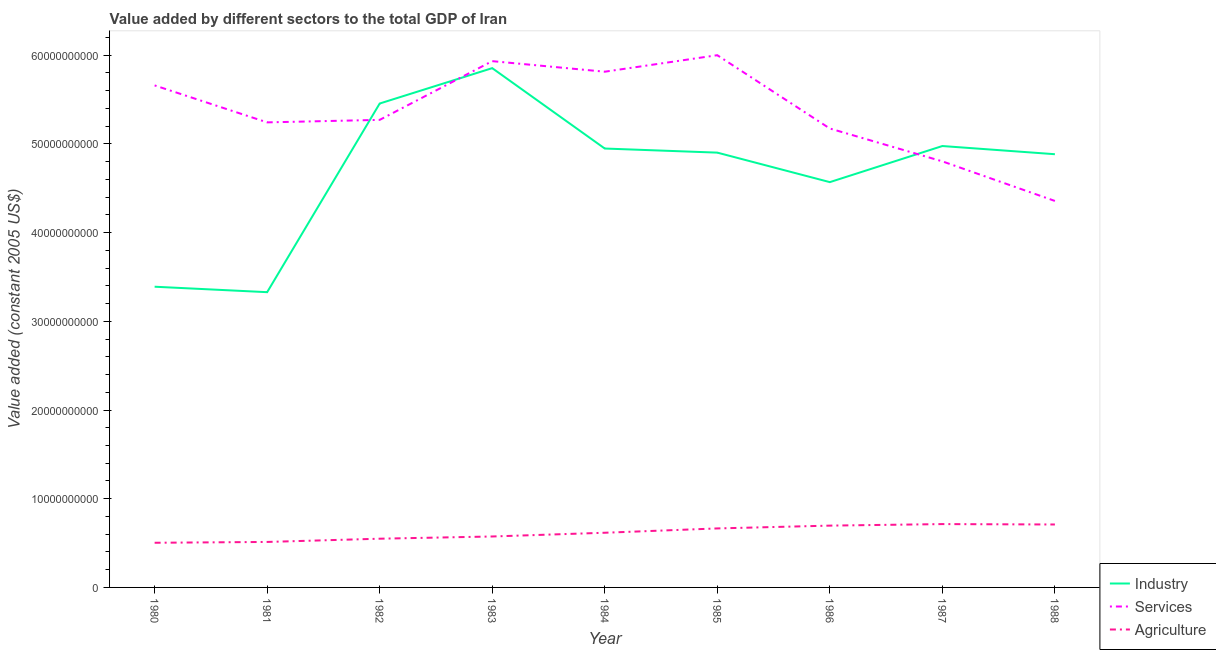Does the line corresponding to value added by industrial sector intersect with the line corresponding to value added by agricultural sector?
Provide a succinct answer. No. Is the number of lines equal to the number of legend labels?
Give a very brief answer. Yes. What is the value added by services in 1983?
Your answer should be compact. 5.93e+1. Across all years, what is the maximum value added by agricultural sector?
Ensure brevity in your answer.  7.14e+09. Across all years, what is the minimum value added by services?
Keep it short and to the point. 4.36e+1. In which year was the value added by industrial sector maximum?
Ensure brevity in your answer.  1983. In which year was the value added by agricultural sector minimum?
Offer a terse response. 1980. What is the total value added by industrial sector in the graph?
Give a very brief answer. 4.23e+11. What is the difference between the value added by industrial sector in 1983 and that in 1988?
Provide a succinct answer. 9.70e+09. What is the difference between the value added by industrial sector in 1988 and the value added by services in 1987?
Give a very brief answer. 8.06e+08. What is the average value added by agricultural sector per year?
Provide a short and direct response. 6.16e+09. In the year 1983, what is the difference between the value added by services and value added by agricultural sector?
Offer a very short reply. 5.36e+1. In how many years, is the value added by industrial sector greater than 40000000000 US$?
Keep it short and to the point. 7. What is the ratio of the value added by services in 1980 to that in 1987?
Your answer should be very brief. 1.18. Is the value added by services in 1980 less than that in 1986?
Your answer should be compact. No. Is the difference between the value added by agricultural sector in 1982 and 1985 greater than the difference between the value added by services in 1982 and 1985?
Offer a terse response. Yes. What is the difference between the highest and the second highest value added by services?
Your answer should be very brief. 6.70e+08. What is the difference between the highest and the lowest value added by agricultural sector?
Make the answer very short. 2.11e+09. Is the value added by industrial sector strictly greater than the value added by services over the years?
Keep it short and to the point. No. How many lines are there?
Provide a succinct answer. 3. What is the difference between two consecutive major ticks on the Y-axis?
Give a very brief answer. 1.00e+1. Are the values on the major ticks of Y-axis written in scientific E-notation?
Offer a terse response. No. Does the graph contain any zero values?
Your response must be concise. No. Where does the legend appear in the graph?
Provide a short and direct response. Bottom right. What is the title of the graph?
Offer a terse response. Value added by different sectors to the total GDP of Iran. Does "Oil" appear as one of the legend labels in the graph?
Offer a very short reply. No. What is the label or title of the Y-axis?
Your response must be concise. Value added (constant 2005 US$). What is the Value added (constant 2005 US$) of Industry in 1980?
Ensure brevity in your answer.  3.39e+1. What is the Value added (constant 2005 US$) in Services in 1980?
Provide a succinct answer. 5.66e+1. What is the Value added (constant 2005 US$) of Agriculture in 1980?
Provide a short and direct response. 5.04e+09. What is the Value added (constant 2005 US$) in Industry in 1981?
Offer a very short reply. 3.33e+1. What is the Value added (constant 2005 US$) in Services in 1981?
Ensure brevity in your answer.  5.24e+1. What is the Value added (constant 2005 US$) of Agriculture in 1981?
Give a very brief answer. 5.13e+09. What is the Value added (constant 2005 US$) of Industry in 1982?
Give a very brief answer. 5.46e+1. What is the Value added (constant 2005 US$) in Services in 1982?
Make the answer very short. 5.27e+1. What is the Value added (constant 2005 US$) of Agriculture in 1982?
Your answer should be compact. 5.49e+09. What is the Value added (constant 2005 US$) in Industry in 1983?
Ensure brevity in your answer.  5.85e+1. What is the Value added (constant 2005 US$) of Services in 1983?
Make the answer very short. 5.93e+1. What is the Value added (constant 2005 US$) of Agriculture in 1983?
Ensure brevity in your answer.  5.74e+09. What is the Value added (constant 2005 US$) in Industry in 1984?
Provide a succinct answer. 4.95e+1. What is the Value added (constant 2005 US$) of Services in 1984?
Give a very brief answer. 5.81e+1. What is the Value added (constant 2005 US$) in Agriculture in 1984?
Ensure brevity in your answer.  6.17e+09. What is the Value added (constant 2005 US$) in Industry in 1985?
Your response must be concise. 4.90e+1. What is the Value added (constant 2005 US$) in Services in 1985?
Make the answer very short. 6.00e+1. What is the Value added (constant 2005 US$) of Agriculture in 1985?
Provide a succinct answer. 6.65e+09. What is the Value added (constant 2005 US$) in Industry in 1986?
Make the answer very short. 4.57e+1. What is the Value added (constant 2005 US$) of Services in 1986?
Your answer should be compact. 5.17e+1. What is the Value added (constant 2005 US$) of Agriculture in 1986?
Offer a terse response. 6.97e+09. What is the Value added (constant 2005 US$) in Industry in 1987?
Keep it short and to the point. 4.98e+1. What is the Value added (constant 2005 US$) of Services in 1987?
Make the answer very short. 4.80e+1. What is the Value added (constant 2005 US$) in Agriculture in 1987?
Your answer should be very brief. 7.14e+09. What is the Value added (constant 2005 US$) in Industry in 1988?
Ensure brevity in your answer.  4.88e+1. What is the Value added (constant 2005 US$) of Services in 1988?
Provide a succinct answer. 4.36e+1. What is the Value added (constant 2005 US$) in Agriculture in 1988?
Make the answer very short. 7.10e+09. Across all years, what is the maximum Value added (constant 2005 US$) in Industry?
Ensure brevity in your answer.  5.85e+1. Across all years, what is the maximum Value added (constant 2005 US$) of Services?
Your response must be concise. 6.00e+1. Across all years, what is the maximum Value added (constant 2005 US$) in Agriculture?
Offer a terse response. 7.14e+09. Across all years, what is the minimum Value added (constant 2005 US$) of Industry?
Make the answer very short. 3.33e+1. Across all years, what is the minimum Value added (constant 2005 US$) in Services?
Your response must be concise. 4.36e+1. Across all years, what is the minimum Value added (constant 2005 US$) of Agriculture?
Give a very brief answer. 5.04e+09. What is the total Value added (constant 2005 US$) in Industry in the graph?
Make the answer very short. 4.23e+11. What is the total Value added (constant 2005 US$) of Services in the graph?
Keep it short and to the point. 4.83e+11. What is the total Value added (constant 2005 US$) of Agriculture in the graph?
Provide a succinct answer. 5.54e+1. What is the difference between the Value added (constant 2005 US$) of Industry in 1980 and that in 1981?
Keep it short and to the point. 6.14e+08. What is the difference between the Value added (constant 2005 US$) of Services in 1980 and that in 1981?
Offer a terse response. 4.17e+09. What is the difference between the Value added (constant 2005 US$) of Agriculture in 1980 and that in 1981?
Make the answer very short. -9.32e+07. What is the difference between the Value added (constant 2005 US$) of Industry in 1980 and that in 1982?
Provide a short and direct response. -2.07e+1. What is the difference between the Value added (constant 2005 US$) of Services in 1980 and that in 1982?
Your response must be concise. 3.89e+09. What is the difference between the Value added (constant 2005 US$) in Agriculture in 1980 and that in 1982?
Provide a succinct answer. -4.58e+08. What is the difference between the Value added (constant 2005 US$) in Industry in 1980 and that in 1983?
Offer a terse response. -2.46e+1. What is the difference between the Value added (constant 2005 US$) in Services in 1980 and that in 1983?
Your answer should be very brief. -2.74e+09. What is the difference between the Value added (constant 2005 US$) of Agriculture in 1980 and that in 1983?
Provide a succinct answer. -7.09e+08. What is the difference between the Value added (constant 2005 US$) in Industry in 1980 and that in 1984?
Keep it short and to the point. -1.56e+1. What is the difference between the Value added (constant 2005 US$) of Services in 1980 and that in 1984?
Your answer should be compact. -1.54e+09. What is the difference between the Value added (constant 2005 US$) in Agriculture in 1980 and that in 1984?
Your answer should be very brief. -1.13e+09. What is the difference between the Value added (constant 2005 US$) of Industry in 1980 and that in 1985?
Provide a succinct answer. -1.51e+1. What is the difference between the Value added (constant 2005 US$) of Services in 1980 and that in 1985?
Your answer should be compact. -3.40e+09. What is the difference between the Value added (constant 2005 US$) in Agriculture in 1980 and that in 1985?
Give a very brief answer. -1.62e+09. What is the difference between the Value added (constant 2005 US$) in Industry in 1980 and that in 1986?
Make the answer very short. -1.18e+1. What is the difference between the Value added (constant 2005 US$) of Services in 1980 and that in 1986?
Your answer should be compact. 4.86e+09. What is the difference between the Value added (constant 2005 US$) in Agriculture in 1980 and that in 1986?
Provide a succinct answer. -1.93e+09. What is the difference between the Value added (constant 2005 US$) of Industry in 1980 and that in 1987?
Provide a short and direct response. -1.59e+1. What is the difference between the Value added (constant 2005 US$) of Services in 1980 and that in 1987?
Your response must be concise. 8.56e+09. What is the difference between the Value added (constant 2005 US$) of Agriculture in 1980 and that in 1987?
Provide a succinct answer. -2.11e+09. What is the difference between the Value added (constant 2005 US$) of Industry in 1980 and that in 1988?
Offer a terse response. -1.49e+1. What is the difference between the Value added (constant 2005 US$) of Services in 1980 and that in 1988?
Make the answer very short. 1.30e+1. What is the difference between the Value added (constant 2005 US$) in Agriculture in 1980 and that in 1988?
Make the answer very short. -2.06e+09. What is the difference between the Value added (constant 2005 US$) in Industry in 1981 and that in 1982?
Offer a terse response. -2.13e+1. What is the difference between the Value added (constant 2005 US$) in Services in 1981 and that in 1982?
Your response must be concise. -2.82e+08. What is the difference between the Value added (constant 2005 US$) of Agriculture in 1981 and that in 1982?
Offer a very short reply. -3.65e+08. What is the difference between the Value added (constant 2005 US$) of Industry in 1981 and that in 1983?
Make the answer very short. -2.53e+1. What is the difference between the Value added (constant 2005 US$) in Services in 1981 and that in 1983?
Make the answer very short. -6.90e+09. What is the difference between the Value added (constant 2005 US$) in Agriculture in 1981 and that in 1983?
Provide a short and direct response. -6.15e+08. What is the difference between the Value added (constant 2005 US$) of Industry in 1981 and that in 1984?
Your response must be concise. -1.62e+1. What is the difference between the Value added (constant 2005 US$) of Services in 1981 and that in 1984?
Keep it short and to the point. -5.71e+09. What is the difference between the Value added (constant 2005 US$) in Agriculture in 1981 and that in 1984?
Provide a succinct answer. -1.04e+09. What is the difference between the Value added (constant 2005 US$) of Industry in 1981 and that in 1985?
Provide a succinct answer. -1.57e+1. What is the difference between the Value added (constant 2005 US$) of Services in 1981 and that in 1985?
Ensure brevity in your answer.  -7.57e+09. What is the difference between the Value added (constant 2005 US$) of Agriculture in 1981 and that in 1985?
Keep it short and to the point. -1.52e+09. What is the difference between the Value added (constant 2005 US$) of Industry in 1981 and that in 1986?
Provide a short and direct response. -1.24e+1. What is the difference between the Value added (constant 2005 US$) of Services in 1981 and that in 1986?
Your answer should be very brief. 6.92e+08. What is the difference between the Value added (constant 2005 US$) of Agriculture in 1981 and that in 1986?
Give a very brief answer. -1.84e+09. What is the difference between the Value added (constant 2005 US$) in Industry in 1981 and that in 1987?
Provide a short and direct response. -1.65e+1. What is the difference between the Value added (constant 2005 US$) of Services in 1981 and that in 1987?
Make the answer very short. 4.40e+09. What is the difference between the Value added (constant 2005 US$) in Agriculture in 1981 and that in 1987?
Keep it short and to the point. -2.01e+09. What is the difference between the Value added (constant 2005 US$) of Industry in 1981 and that in 1988?
Give a very brief answer. -1.56e+1. What is the difference between the Value added (constant 2005 US$) in Services in 1981 and that in 1988?
Provide a succinct answer. 8.86e+09. What is the difference between the Value added (constant 2005 US$) in Agriculture in 1981 and that in 1988?
Provide a succinct answer. -1.97e+09. What is the difference between the Value added (constant 2005 US$) of Industry in 1982 and that in 1983?
Provide a succinct answer. -3.99e+09. What is the difference between the Value added (constant 2005 US$) of Services in 1982 and that in 1983?
Provide a succinct answer. -6.62e+09. What is the difference between the Value added (constant 2005 US$) in Agriculture in 1982 and that in 1983?
Provide a succinct answer. -2.50e+08. What is the difference between the Value added (constant 2005 US$) of Industry in 1982 and that in 1984?
Make the answer very short. 5.08e+09. What is the difference between the Value added (constant 2005 US$) of Services in 1982 and that in 1984?
Give a very brief answer. -5.43e+09. What is the difference between the Value added (constant 2005 US$) in Agriculture in 1982 and that in 1984?
Provide a succinct answer. -6.72e+08. What is the difference between the Value added (constant 2005 US$) in Industry in 1982 and that in 1985?
Give a very brief answer. 5.54e+09. What is the difference between the Value added (constant 2005 US$) in Services in 1982 and that in 1985?
Provide a short and direct response. -7.29e+09. What is the difference between the Value added (constant 2005 US$) in Agriculture in 1982 and that in 1985?
Your response must be concise. -1.16e+09. What is the difference between the Value added (constant 2005 US$) in Industry in 1982 and that in 1986?
Give a very brief answer. 8.86e+09. What is the difference between the Value added (constant 2005 US$) of Services in 1982 and that in 1986?
Your answer should be very brief. 9.74e+08. What is the difference between the Value added (constant 2005 US$) in Agriculture in 1982 and that in 1986?
Ensure brevity in your answer.  -1.47e+09. What is the difference between the Value added (constant 2005 US$) in Industry in 1982 and that in 1987?
Offer a very short reply. 4.79e+09. What is the difference between the Value added (constant 2005 US$) in Services in 1982 and that in 1987?
Your answer should be compact. 4.68e+09. What is the difference between the Value added (constant 2005 US$) in Agriculture in 1982 and that in 1987?
Your answer should be compact. -1.65e+09. What is the difference between the Value added (constant 2005 US$) in Industry in 1982 and that in 1988?
Offer a very short reply. 5.72e+09. What is the difference between the Value added (constant 2005 US$) of Services in 1982 and that in 1988?
Give a very brief answer. 9.14e+09. What is the difference between the Value added (constant 2005 US$) in Agriculture in 1982 and that in 1988?
Give a very brief answer. -1.60e+09. What is the difference between the Value added (constant 2005 US$) of Industry in 1983 and that in 1984?
Keep it short and to the point. 9.06e+09. What is the difference between the Value added (constant 2005 US$) of Services in 1983 and that in 1984?
Your answer should be very brief. 1.19e+09. What is the difference between the Value added (constant 2005 US$) of Agriculture in 1983 and that in 1984?
Ensure brevity in your answer.  -4.22e+08. What is the difference between the Value added (constant 2005 US$) of Industry in 1983 and that in 1985?
Give a very brief answer. 9.53e+09. What is the difference between the Value added (constant 2005 US$) in Services in 1983 and that in 1985?
Provide a short and direct response. -6.70e+08. What is the difference between the Value added (constant 2005 US$) in Agriculture in 1983 and that in 1985?
Provide a succinct answer. -9.09e+08. What is the difference between the Value added (constant 2005 US$) of Industry in 1983 and that in 1986?
Provide a short and direct response. 1.29e+1. What is the difference between the Value added (constant 2005 US$) of Services in 1983 and that in 1986?
Your answer should be compact. 7.60e+09. What is the difference between the Value added (constant 2005 US$) of Agriculture in 1983 and that in 1986?
Keep it short and to the point. -1.22e+09. What is the difference between the Value added (constant 2005 US$) of Industry in 1983 and that in 1987?
Your answer should be very brief. 8.78e+09. What is the difference between the Value added (constant 2005 US$) in Services in 1983 and that in 1987?
Your response must be concise. 1.13e+1. What is the difference between the Value added (constant 2005 US$) of Agriculture in 1983 and that in 1987?
Give a very brief answer. -1.40e+09. What is the difference between the Value added (constant 2005 US$) in Industry in 1983 and that in 1988?
Your response must be concise. 9.70e+09. What is the difference between the Value added (constant 2005 US$) of Services in 1983 and that in 1988?
Make the answer very short. 1.58e+1. What is the difference between the Value added (constant 2005 US$) of Agriculture in 1983 and that in 1988?
Provide a succinct answer. -1.35e+09. What is the difference between the Value added (constant 2005 US$) of Industry in 1984 and that in 1985?
Provide a succinct answer. 4.61e+08. What is the difference between the Value added (constant 2005 US$) in Services in 1984 and that in 1985?
Give a very brief answer. -1.86e+09. What is the difference between the Value added (constant 2005 US$) in Agriculture in 1984 and that in 1985?
Offer a very short reply. -4.87e+08. What is the difference between the Value added (constant 2005 US$) in Industry in 1984 and that in 1986?
Your answer should be very brief. 3.79e+09. What is the difference between the Value added (constant 2005 US$) of Services in 1984 and that in 1986?
Provide a succinct answer. 6.40e+09. What is the difference between the Value added (constant 2005 US$) of Agriculture in 1984 and that in 1986?
Your answer should be very brief. -8.03e+08. What is the difference between the Value added (constant 2005 US$) in Industry in 1984 and that in 1987?
Provide a succinct answer. -2.82e+08. What is the difference between the Value added (constant 2005 US$) in Services in 1984 and that in 1987?
Your answer should be very brief. 1.01e+1. What is the difference between the Value added (constant 2005 US$) of Agriculture in 1984 and that in 1987?
Keep it short and to the point. -9.76e+08. What is the difference between the Value added (constant 2005 US$) of Industry in 1984 and that in 1988?
Your response must be concise. 6.40e+08. What is the difference between the Value added (constant 2005 US$) of Services in 1984 and that in 1988?
Provide a succinct answer. 1.46e+1. What is the difference between the Value added (constant 2005 US$) in Agriculture in 1984 and that in 1988?
Your response must be concise. -9.30e+08. What is the difference between the Value added (constant 2005 US$) in Industry in 1985 and that in 1986?
Provide a short and direct response. 3.33e+09. What is the difference between the Value added (constant 2005 US$) of Services in 1985 and that in 1986?
Your response must be concise. 8.26e+09. What is the difference between the Value added (constant 2005 US$) in Agriculture in 1985 and that in 1986?
Offer a terse response. -3.16e+08. What is the difference between the Value added (constant 2005 US$) in Industry in 1985 and that in 1987?
Keep it short and to the point. -7.43e+08. What is the difference between the Value added (constant 2005 US$) of Services in 1985 and that in 1987?
Ensure brevity in your answer.  1.20e+1. What is the difference between the Value added (constant 2005 US$) of Agriculture in 1985 and that in 1987?
Your answer should be compact. -4.89e+08. What is the difference between the Value added (constant 2005 US$) in Industry in 1985 and that in 1988?
Offer a terse response. 1.79e+08. What is the difference between the Value added (constant 2005 US$) in Services in 1985 and that in 1988?
Your response must be concise. 1.64e+1. What is the difference between the Value added (constant 2005 US$) of Agriculture in 1985 and that in 1988?
Provide a succinct answer. -4.43e+08. What is the difference between the Value added (constant 2005 US$) in Industry in 1986 and that in 1987?
Make the answer very short. -4.07e+09. What is the difference between the Value added (constant 2005 US$) of Services in 1986 and that in 1987?
Give a very brief answer. 3.70e+09. What is the difference between the Value added (constant 2005 US$) in Agriculture in 1986 and that in 1987?
Your answer should be compact. -1.73e+08. What is the difference between the Value added (constant 2005 US$) of Industry in 1986 and that in 1988?
Your answer should be compact. -3.15e+09. What is the difference between the Value added (constant 2005 US$) in Services in 1986 and that in 1988?
Your answer should be compact. 8.17e+09. What is the difference between the Value added (constant 2005 US$) of Agriculture in 1986 and that in 1988?
Make the answer very short. -1.27e+08. What is the difference between the Value added (constant 2005 US$) in Industry in 1987 and that in 1988?
Offer a very short reply. 9.22e+08. What is the difference between the Value added (constant 2005 US$) of Services in 1987 and that in 1988?
Offer a very short reply. 4.46e+09. What is the difference between the Value added (constant 2005 US$) of Agriculture in 1987 and that in 1988?
Provide a succinct answer. 4.59e+07. What is the difference between the Value added (constant 2005 US$) of Industry in 1980 and the Value added (constant 2005 US$) of Services in 1981?
Provide a succinct answer. -1.85e+1. What is the difference between the Value added (constant 2005 US$) in Industry in 1980 and the Value added (constant 2005 US$) in Agriculture in 1981?
Give a very brief answer. 2.88e+1. What is the difference between the Value added (constant 2005 US$) in Services in 1980 and the Value added (constant 2005 US$) in Agriculture in 1981?
Provide a short and direct response. 5.15e+1. What is the difference between the Value added (constant 2005 US$) of Industry in 1980 and the Value added (constant 2005 US$) of Services in 1982?
Provide a short and direct response. -1.88e+1. What is the difference between the Value added (constant 2005 US$) of Industry in 1980 and the Value added (constant 2005 US$) of Agriculture in 1982?
Make the answer very short. 2.84e+1. What is the difference between the Value added (constant 2005 US$) in Services in 1980 and the Value added (constant 2005 US$) in Agriculture in 1982?
Your answer should be very brief. 5.11e+1. What is the difference between the Value added (constant 2005 US$) of Industry in 1980 and the Value added (constant 2005 US$) of Services in 1983?
Provide a short and direct response. -2.54e+1. What is the difference between the Value added (constant 2005 US$) of Industry in 1980 and the Value added (constant 2005 US$) of Agriculture in 1983?
Your answer should be compact. 2.82e+1. What is the difference between the Value added (constant 2005 US$) in Services in 1980 and the Value added (constant 2005 US$) in Agriculture in 1983?
Make the answer very short. 5.09e+1. What is the difference between the Value added (constant 2005 US$) in Industry in 1980 and the Value added (constant 2005 US$) in Services in 1984?
Your answer should be compact. -2.42e+1. What is the difference between the Value added (constant 2005 US$) in Industry in 1980 and the Value added (constant 2005 US$) in Agriculture in 1984?
Give a very brief answer. 2.77e+1. What is the difference between the Value added (constant 2005 US$) in Services in 1980 and the Value added (constant 2005 US$) in Agriculture in 1984?
Offer a terse response. 5.04e+1. What is the difference between the Value added (constant 2005 US$) in Industry in 1980 and the Value added (constant 2005 US$) in Services in 1985?
Make the answer very short. -2.61e+1. What is the difference between the Value added (constant 2005 US$) of Industry in 1980 and the Value added (constant 2005 US$) of Agriculture in 1985?
Provide a succinct answer. 2.73e+1. What is the difference between the Value added (constant 2005 US$) of Services in 1980 and the Value added (constant 2005 US$) of Agriculture in 1985?
Offer a very short reply. 4.99e+1. What is the difference between the Value added (constant 2005 US$) of Industry in 1980 and the Value added (constant 2005 US$) of Services in 1986?
Make the answer very short. -1.78e+1. What is the difference between the Value added (constant 2005 US$) in Industry in 1980 and the Value added (constant 2005 US$) in Agriculture in 1986?
Your answer should be very brief. 2.69e+1. What is the difference between the Value added (constant 2005 US$) of Services in 1980 and the Value added (constant 2005 US$) of Agriculture in 1986?
Your answer should be very brief. 4.96e+1. What is the difference between the Value added (constant 2005 US$) of Industry in 1980 and the Value added (constant 2005 US$) of Services in 1987?
Your response must be concise. -1.41e+1. What is the difference between the Value added (constant 2005 US$) of Industry in 1980 and the Value added (constant 2005 US$) of Agriculture in 1987?
Ensure brevity in your answer.  2.68e+1. What is the difference between the Value added (constant 2005 US$) in Services in 1980 and the Value added (constant 2005 US$) in Agriculture in 1987?
Give a very brief answer. 4.95e+1. What is the difference between the Value added (constant 2005 US$) of Industry in 1980 and the Value added (constant 2005 US$) of Services in 1988?
Make the answer very short. -9.67e+09. What is the difference between the Value added (constant 2005 US$) of Industry in 1980 and the Value added (constant 2005 US$) of Agriculture in 1988?
Give a very brief answer. 2.68e+1. What is the difference between the Value added (constant 2005 US$) of Services in 1980 and the Value added (constant 2005 US$) of Agriculture in 1988?
Your response must be concise. 4.95e+1. What is the difference between the Value added (constant 2005 US$) in Industry in 1981 and the Value added (constant 2005 US$) in Services in 1982?
Your response must be concise. -1.94e+1. What is the difference between the Value added (constant 2005 US$) of Industry in 1981 and the Value added (constant 2005 US$) of Agriculture in 1982?
Offer a very short reply. 2.78e+1. What is the difference between the Value added (constant 2005 US$) of Services in 1981 and the Value added (constant 2005 US$) of Agriculture in 1982?
Keep it short and to the point. 4.69e+1. What is the difference between the Value added (constant 2005 US$) of Industry in 1981 and the Value added (constant 2005 US$) of Services in 1983?
Make the answer very short. -2.60e+1. What is the difference between the Value added (constant 2005 US$) in Industry in 1981 and the Value added (constant 2005 US$) in Agriculture in 1983?
Offer a very short reply. 2.75e+1. What is the difference between the Value added (constant 2005 US$) of Services in 1981 and the Value added (constant 2005 US$) of Agriculture in 1983?
Offer a very short reply. 4.67e+1. What is the difference between the Value added (constant 2005 US$) of Industry in 1981 and the Value added (constant 2005 US$) of Services in 1984?
Provide a succinct answer. -2.49e+1. What is the difference between the Value added (constant 2005 US$) of Industry in 1981 and the Value added (constant 2005 US$) of Agriculture in 1984?
Make the answer very short. 2.71e+1. What is the difference between the Value added (constant 2005 US$) in Services in 1981 and the Value added (constant 2005 US$) in Agriculture in 1984?
Offer a terse response. 4.63e+1. What is the difference between the Value added (constant 2005 US$) of Industry in 1981 and the Value added (constant 2005 US$) of Services in 1985?
Offer a very short reply. -2.67e+1. What is the difference between the Value added (constant 2005 US$) in Industry in 1981 and the Value added (constant 2005 US$) in Agriculture in 1985?
Make the answer very short. 2.66e+1. What is the difference between the Value added (constant 2005 US$) in Services in 1981 and the Value added (constant 2005 US$) in Agriculture in 1985?
Your answer should be compact. 4.58e+1. What is the difference between the Value added (constant 2005 US$) of Industry in 1981 and the Value added (constant 2005 US$) of Services in 1986?
Offer a terse response. -1.85e+1. What is the difference between the Value added (constant 2005 US$) of Industry in 1981 and the Value added (constant 2005 US$) of Agriculture in 1986?
Your answer should be very brief. 2.63e+1. What is the difference between the Value added (constant 2005 US$) in Services in 1981 and the Value added (constant 2005 US$) in Agriculture in 1986?
Ensure brevity in your answer.  4.55e+1. What is the difference between the Value added (constant 2005 US$) in Industry in 1981 and the Value added (constant 2005 US$) in Services in 1987?
Make the answer very short. -1.47e+1. What is the difference between the Value added (constant 2005 US$) in Industry in 1981 and the Value added (constant 2005 US$) in Agriculture in 1987?
Your answer should be compact. 2.61e+1. What is the difference between the Value added (constant 2005 US$) of Services in 1981 and the Value added (constant 2005 US$) of Agriculture in 1987?
Make the answer very short. 4.53e+1. What is the difference between the Value added (constant 2005 US$) of Industry in 1981 and the Value added (constant 2005 US$) of Services in 1988?
Provide a succinct answer. -1.03e+1. What is the difference between the Value added (constant 2005 US$) in Industry in 1981 and the Value added (constant 2005 US$) in Agriculture in 1988?
Your answer should be very brief. 2.62e+1. What is the difference between the Value added (constant 2005 US$) in Services in 1981 and the Value added (constant 2005 US$) in Agriculture in 1988?
Offer a terse response. 4.53e+1. What is the difference between the Value added (constant 2005 US$) in Industry in 1982 and the Value added (constant 2005 US$) in Services in 1983?
Make the answer very short. -4.78e+09. What is the difference between the Value added (constant 2005 US$) in Industry in 1982 and the Value added (constant 2005 US$) in Agriculture in 1983?
Give a very brief answer. 4.88e+1. What is the difference between the Value added (constant 2005 US$) of Services in 1982 and the Value added (constant 2005 US$) of Agriculture in 1983?
Offer a terse response. 4.70e+1. What is the difference between the Value added (constant 2005 US$) of Industry in 1982 and the Value added (constant 2005 US$) of Services in 1984?
Ensure brevity in your answer.  -3.59e+09. What is the difference between the Value added (constant 2005 US$) of Industry in 1982 and the Value added (constant 2005 US$) of Agriculture in 1984?
Provide a succinct answer. 4.84e+1. What is the difference between the Value added (constant 2005 US$) of Services in 1982 and the Value added (constant 2005 US$) of Agriculture in 1984?
Your response must be concise. 4.65e+1. What is the difference between the Value added (constant 2005 US$) in Industry in 1982 and the Value added (constant 2005 US$) in Services in 1985?
Your answer should be compact. -5.45e+09. What is the difference between the Value added (constant 2005 US$) in Industry in 1982 and the Value added (constant 2005 US$) in Agriculture in 1985?
Offer a very short reply. 4.79e+1. What is the difference between the Value added (constant 2005 US$) of Services in 1982 and the Value added (constant 2005 US$) of Agriculture in 1985?
Ensure brevity in your answer.  4.61e+1. What is the difference between the Value added (constant 2005 US$) in Industry in 1982 and the Value added (constant 2005 US$) in Services in 1986?
Your response must be concise. 2.82e+09. What is the difference between the Value added (constant 2005 US$) in Industry in 1982 and the Value added (constant 2005 US$) in Agriculture in 1986?
Provide a short and direct response. 4.76e+1. What is the difference between the Value added (constant 2005 US$) of Services in 1982 and the Value added (constant 2005 US$) of Agriculture in 1986?
Give a very brief answer. 4.57e+1. What is the difference between the Value added (constant 2005 US$) of Industry in 1982 and the Value added (constant 2005 US$) of Services in 1987?
Give a very brief answer. 6.52e+09. What is the difference between the Value added (constant 2005 US$) in Industry in 1982 and the Value added (constant 2005 US$) in Agriculture in 1987?
Offer a terse response. 4.74e+1. What is the difference between the Value added (constant 2005 US$) of Services in 1982 and the Value added (constant 2005 US$) of Agriculture in 1987?
Provide a succinct answer. 4.56e+1. What is the difference between the Value added (constant 2005 US$) in Industry in 1982 and the Value added (constant 2005 US$) in Services in 1988?
Offer a very short reply. 1.10e+1. What is the difference between the Value added (constant 2005 US$) in Industry in 1982 and the Value added (constant 2005 US$) in Agriculture in 1988?
Your answer should be very brief. 4.75e+1. What is the difference between the Value added (constant 2005 US$) of Services in 1982 and the Value added (constant 2005 US$) of Agriculture in 1988?
Keep it short and to the point. 4.56e+1. What is the difference between the Value added (constant 2005 US$) in Industry in 1983 and the Value added (constant 2005 US$) in Services in 1984?
Your response must be concise. 4.02e+08. What is the difference between the Value added (constant 2005 US$) in Industry in 1983 and the Value added (constant 2005 US$) in Agriculture in 1984?
Ensure brevity in your answer.  5.24e+1. What is the difference between the Value added (constant 2005 US$) in Services in 1983 and the Value added (constant 2005 US$) in Agriculture in 1984?
Make the answer very short. 5.32e+1. What is the difference between the Value added (constant 2005 US$) in Industry in 1983 and the Value added (constant 2005 US$) in Services in 1985?
Your answer should be compact. -1.46e+09. What is the difference between the Value added (constant 2005 US$) of Industry in 1983 and the Value added (constant 2005 US$) of Agriculture in 1985?
Your response must be concise. 5.19e+1. What is the difference between the Value added (constant 2005 US$) in Services in 1983 and the Value added (constant 2005 US$) in Agriculture in 1985?
Provide a succinct answer. 5.27e+1. What is the difference between the Value added (constant 2005 US$) of Industry in 1983 and the Value added (constant 2005 US$) of Services in 1986?
Ensure brevity in your answer.  6.81e+09. What is the difference between the Value added (constant 2005 US$) of Industry in 1983 and the Value added (constant 2005 US$) of Agriculture in 1986?
Ensure brevity in your answer.  5.16e+1. What is the difference between the Value added (constant 2005 US$) in Services in 1983 and the Value added (constant 2005 US$) in Agriculture in 1986?
Provide a short and direct response. 5.24e+1. What is the difference between the Value added (constant 2005 US$) of Industry in 1983 and the Value added (constant 2005 US$) of Services in 1987?
Give a very brief answer. 1.05e+1. What is the difference between the Value added (constant 2005 US$) in Industry in 1983 and the Value added (constant 2005 US$) in Agriculture in 1987?
Offer a terse response. 5.14e+1. What is the difference between the Value added (constant 2005 US$) of Services in 1983 and the Value added (constant 2005 US$) of Agriculture in 1987?
Ensure brevity in your answer.  5.22e+1. What is the difference between the Value added (constant 2005 US$) of Industry in 1983 and the Value added (constant 2005 US$) of Services in 1988?
Make the answer very short. 1.50e+1. What is the difference between the Value added (constant 2005 US$) in Industry in 1983 and the Value added (constant 2005 US$) in Agriculture in 1988?
Keep it short and to the point. 5.15e+1. What is the difference between the Value added (constant 2005 US$) in Services in 1983 and the Value added (constant 2005 US$) in Agriculture in 1988?
Keep it short and to the point. 5.22e+1. What is the difference between the Value added (constant 2005 US$) of Industry in 1984 and the Value added (constant 2005 US$) of Services in 1985?
Ensure brevity in your answer.  -1.05e+1. What is the difference between the Value added (constant 2005 US$) of Industry in 1984 and the Value added (constant 2005 US$) of Agriculture in 1985?
Give a very brief answer. 4.28e+1. What is the difference between the Value added (constant 2005 US$) of Services in 1984 and the Value added (constant 2005 US$) of Agriculture in 1985?
Your response must be concise. 5.15e+1. What is the difference between the Value added (constant 2005 US$) in Industry in 1984 and the Value added (constant 2005 US$) in Services in 1986?
Keep it short and to the point. -2.26e+09. What is the difference between the Value added (constant 2005 US$) in Industry in 1984 and the Value added (constant 2005 US$) in Agriculture in 1986?
Keep it short and to the point. 4.25e+1. What is the difference between the Value added (constant 2005 US$) in Services in 1984 and the Value added (constant 2005 US$) in Agriculture in 1986?
Your answer should be compact. 5.12e+1. What is the difference between the Value added (constant 2005 US$) of Industry in 1984 and the Value added (constant 2005 US$) of Services in 1987?
Your response must be concise. 1.45e+09. What is the difference between the Value added (constant 2005 US$) of Industry in 1984 and the Value added (constant 2005 US$) of Agriculture in 1987?
Offer a very short reply. 4.23e+1. What is the difference between the Value added (constant 2005 US$) of Services in 1984 and the Value added (constant 2005 US$) of Agriculture in 1987?
Provide a succinct answer. 5.10e+1. What is the difference between the Value added (constant 2005 US$) in Industry in 1984 and the Value added (constant 2005 US$) in Services in 1988?
Your response must be concise. 5.91e+09. What is the difference between the Value added (constant 2005 US$) in Industry in 1984 and the Value added (constant 2005 US$) in Agriculture in 1988?
Offer a terse response. 4.24e+1. What is the difference between the Value added (constant 2005 US$) of Services in 1984 and the Value added (constant 2005 US$) of Agriculture in 1988?
Make the answer very short. 5.10e+1. What is the difference between the Value added (constant 2005 US$) of Industry in 1985 and the Value added (constant 2005 US$) of Services in 1986?
Provide a short and direct response. -2.72e+09. What is the difference between the Value added (constant 2005 US$) in Industry in 1985 and the Value added (constant 2005 US$) in Agriculture in 1986?
Offer a very short reply. 4.21e+1. What is the difference between the Value added (constant 2005 US$) in Services in 1985 and the Value added (constant 2005 US$) in Agriculture in 1986?
Provide a succinct answer. 5.30e+1. What is the difference between the Value added (constant 2005 US$) of Industry in 1985 and the Value added (constant 2005 US$) of Services in 1987?
Provide a short and direct response. 9.85e+08. What is the difference between the Value added (constant 2005 US$) of Industry in 1985 and the Value added (constant 2005 US$) of Agriculture in 1987?
Make the answer very short. 4.19e+1. What is the difference between the Value added (constant 2005 US$) in Services in 1985 and the Value added (constant 2005 US$) in Agriculture in 1987?
Offer a very short reply. 5.29e+1. What is the difference between the Value added (constant 2005 US$) of Industry in 1985 and the Value added (constant 2005 US$) of Services in 1988?
Your answer should be compact. 5.45e+09. What is the difference between the Value added (constant 2005 US$) of Industry in 1985 and the Value added (constant 2005 US$) of Agriculture in 1988?
Offer a very short reply. 4.19e+1. What is the difference between the Value added (constant 2005 US$) of Services in 1985 and the Value added (constant 2005 US$) of Agriculture in 1988?
Give a very brief answer. 5.29e+1. What is the difference between the Value added (constant 2005 US$) of Industry in 1986 and the Value added (constant 2005 US$) of Services in 1987?
Your answer should be compact. -2.34e+09. What is the difference between the Value added (constant 2005 US$) in Industry in 1986 and the Value added (constant 2005 US$) in Agriculture in 1987?
Provide a short and direct response. 3.86e+1. What is the difference between the Value added (constant 2005 US$) of Services in 1986 and the Value added (constant 2005 US$) of Agriculture in 1987?
Provide a succinct answer. 4.46e+1. What is the difference between the Value added (constant 2005 US$) in Industry in 1986 and the Value added (constant 2005 US$) in Services in 1988?
Give a very brief answer. 2.12e+09. What is the difference between the Value added (constant 2005 US$) in Industry in 1986 and the Value added (constant 2005 US$) in Agriculture in 1988?
Offer a terse response. 3.86e+1. What is the difference between the Value added (constant 2005 US$) in Services in 1986 and the Value added (constant 2005 US$) in Agriculture in 1988?
Offer a terse response. 4.46e+1. What is the difference between the Value added (constant 2005 US$) of Industry in 1987 and the Value added (constant 2005 US$) of Services in 1988?
Provide a short and direct response. 6.19e+09. What is the difference between the Value added (constant 2005 US$) in Industry in 1987 and the Value added (constant 2005 US$) in Agriculture in 1988?
Provide a succinct answer. 4.27e+1. What is the difference between the Value added (constant 2005 US$) of Services in 1987 and the Value added (constant 2005 US$) of Agriculture in 1988?
Offer a terse response. 4.09e+1. What is the average Value added (constant 2005 US$) of Industry per year?
Keep it short and to the point. 4.70e+1. What is the average Value added (constant 2005 US$) in Services per year?
Your answer should be compact. 5.36e+1. What is the average Value added (constant 2005 US$) of Agriculture per year?
Provide a short and direct response. 6.16e+09. In the year 1980, what is the difference between the Value added (constant 2005 US$) of Industry and Value added (constant 2005 US$) of Services?
Provide a succinct answer. -2.27e+1. In the year 1980, what is the difference between the Value added (constant 2005 US$) of Industry and Value added (constant 2005 US$) of Agriculture?
Offer a very short reply. 2.89e+1. In the year 1980, what is the difference between the Value added (constant 2005 US$) in Services and Value added (constant 2005 US$) in Agriculture?
Ensure brevity in your answer.  5.16e+1. In the year 1981, what is the difference between the Value added (constant 2005 US$) of Industry and Value added (constant 2005 US$) of Services?
Provide a short and direct response. -1.91e+1. In the year 1981, what is the difference between the Value added (constant 2005 US$) in Industry and Value added (constant 2005 US$) in Agriculture?
Your answer should be compact. 2.82e+1. In the year 1981, what is the difference between the Value added (constant 2005 US$) of Services and Value added (constant 2005 US$) of Agriculture?
Keep it short and to the point. 4.73e+1. In the year 1982, what is the difference between the Value added (constant 2005 US$) of Industry and Value added (constant 2005 US$) of Services?
Keep it short and to the point. 1.84e+09. In the year 1982, what is the difference between the Value added (constant 2005 US$) in Industry and Value added (constant 2005 US$) in Agriculture?
Your answer should be very brief. 4.91e+1. In the year 1982, what is the difference between the Value added (constant 2005 US$) of Services and Value added (constant 2005 US$) of Agriculture?
Provide a short and direct response. 4.72e+1. In the year 1983, what is the difference between the Value added (constant 2005 US$) of Industry and Value added (constant 2005 US$) of Services?
Offer a very short reply. -7.89e+08. In the year 1983, what is the difference between the Value added (constant 2005 US$) of Industry and Value added (constant 2005 US$) of Agriculture?
Your answer should be compact. 5.28e+1. In the year 1983, what is the difference between the Value added (constant 2005 US$) in Services and Value added (constant 2005 US$) in Agriculture?
Provide a succinct answer. 5.36e+1. In the year 1984, what is the difference between the Value added (constant 2005 US$) of Industry and Value added (constant 2005 US$) of Services?
Ensure brevity in your answer.  -8.66e+09. In the year 1984, what is the difference between the Value added (constant 2005 US$) in Industry and Value added (constant 2005 US$) in Agriculture?
Provide a short and direct response. 4.33e+1. In the year 1984, what is the difference between the Value added (constant 2005 US$) in Services and Value added (constant 2005 US$) in Agriculture?
Your answer should be compact. 5.20e+1. In the year 1985, what is the difference between the Value added (constant 2005 US$) in Industry and Value added (constant 2005 US$) in Services?
Ensure brevity in your answer.  -1.10e+1. In the year 1985, what is the difference between the Value added (constant 2005 US$) in Industry and Value added (constant 2005 US$) in Agriculture?
Keep it short and to the point. 4.24e+1. In the year 1985, what is the difference between the Value added (constant 2005 US$) of Services and Value added (constant 2005 US$) of Agriculture?
Provide a succinct answer. 5.34e+1. In the year 1986, what is the difference between the Value added (constant 2005 US$) of Industry and Value added (constant 2005 US$) of Services?
Make the answer very short. -6.05e+09. In the year 1986, what is the difference between the Value added (constant 2005 US$) in Industry and Value added (constant 2005 US$) in Agriculture?
Provide a succinct answer. 3.87e+1. In the year 1986, what is the difference between the Value added (constant 2005 US$) in Services and Value added (constant 2005 US$) in Agriculture?
Offer a terse response. 4.48e+1. In the year 1987, what is the difference between the Value added (constant 2005 US$) of Industry and Value added (constant 2005 US$) of Services?
Give a very brief answer. 1.73e+09. In the year 1987, what is the difference between the Value added (constant 2005 US$) of Industry and Value added (constant 2005 US$) of Agriculture?
Provide a succinct answer. 4.26e+1. In the year 1987, what is the difference between the Value added (constant 2005 US$) of Services and Value added (constant 2005 US$) of Agriculture?
Provide a succinct answer. 4.09e+1. In the year 1988, what is the difference between the Value added (constant 2005 US$) of Industry and Value added (constant 2005 US$) of Services?
Give a very brief answer. 5.27e+09. In the year 1988, what is the difference between the Value added (constant 2005 US$) of Industry and Value added (constant 2005 US$) of Agriculture?
Provide a succinct answer. 4.17e+1. In the year 1988, what is the difference between the Value added (constant 2005 US$) of Services and Value added (constant 2005 US$) of Agriculture?
Your answer should be very brief. 3.65e+1. What is the ratio of the Value added (constant 2005 US$) in Industry in 1980 to that in 1981?
Give a very brief answer. 1.02. What is the ratio of the Value added (constant 2005 US$) of Services in 1980 to that in 1981?
Make the answer very short. 1.08. What is the ratio of the Value added (constant 2005 US$) of Agriculture in 1980 to that in 1981?
Offer a very short reply. 0.98. What is the ratio of the Value added (constant 2005 US$) of Industry in 1980 to that in 1982?
Give a very brief answer. 0.62. What is the ratio of the Value added (constant 2005 US$) of Services in 1980 to that in 1982?
Provide a succinct answer. 1.07. What is the ratio of the Value added (constant 2005 US$) in Agriculture in 1980 to that in 1982?
Ensure brevity in your answer.  0.92. What is the ratio of the Value added (constant 2005 US$) in Industry in 1980 to that in 1983?
Give a very brief answer. 0.58. What is the ratio of the Value added (constant 2005 US$) of Services in 1980 to that in 1983?
Offer a very short reply. 0.95. What is the ratio of the Value added (constant 2005 US$) in Agriculture in 1980 to that in 1983?
Give a very brief answer. 0.88. What is the ratio of the Value added (constant 2005 US$) of Industry in 1980 to that in 1984?
Give a very brief answer. 0.69. What is the ratio of the Value added (constant 2005 US$) of Services in 1980 to that in 1984?
Your response must be concise. 0.97. What is the ratio of the Value added (constant 2005 US$) in Agriculture in 1980 to that in 1984?
Offer a very short reply. 0.82. What is the ratio of the Value added (constant 2005 US$) of Industry in 1980 to that in 1985?
Offer a terse response. 0.69. What is the ratio of the Value added (constant 2005 US$) in Services in 1980 to that in 1985?
Your answer should be compact. 0.94. What is the ratio of the Value added (constant 2005 US$) in Agriculture in 1980 to that in 1985?
Your answer should be compact. 0.76. What is the ratio of the Value added (constant 2005 US$) in Industry in 1980 to that in 1986?
Provide a succinct answer. 0.74. What is the ratio of the Value added (constant 2005 US$) in Services in 1980 to that in 1986?
Provide a succinct answer. 1.09. What is the ratio of the Value added (constant 2005 US$) of Agriculture in 1980 to that in 1986?
Your answer should be very brief. 0.72. What is the ratio of the Value added (constant 2005 US$) of Industry in 1980 to that in 1987?
Ensure brevity in your answer.  0.68. What is the ratio of the Value added (constant 2005 US$) of Services in 1980 to that in 1987?
Keep it short and to the point. 1.18. What is the ratio of the Value added (constant 2005 US$) of Agriculture in 1980 to that in 1987?
Your answer should be very brief. 0.7. What is the ratio of the Value added (constant 2005 US$) of Industry in 1980 to that in 1988?
Provide a short and direct response. 0.69. What is the ratio of the Value added (constant 2005 US$) of Services in 1980 to that in 1988?
Your answer should be compact. 1.3. What is the ratio of the Value added (constant 2005 US$) of Agriculture in 1980 to that in 1988?
Provide a succinct answer. 0.71. What is the ratio of the Value added (constant 2005 US$) of Industry in 1981 to that in 1982?
Make the answer very short. 0.61. What is the ratio of the Value added (constant 2005 US$) of Services in 1981 to that in 1982?
Offer a terse response. 0.99. What is the ratio of the Value added (constant 2005 US$) in Agriculture in 1981 to that in 1982?
Make the answer very short. 0.93. What is the ratio of the Value added (constant 2005 US$) in Industry in 1981 to that in 1983?
Give a very brief answer. 0.57. What is the ratio of the Value added (constant 2005 US$) in Services in 1981 to that in 1983?
Ensure brevity in your answer.  0.88. What is the ratio of the Value added (constant 2005 US$) of Agriculture in 1981 to that in 1983?
Give a very brief answer. 0.89. What is the ratio of the Value added (constant 2005 US$) in Industry in 1981 to that in 1984?
Provide a short and direct response. 0.67. What is the ratio of the Value added (constant 2005 US$) in Services in 1981 to that in 1984?
Provide a short and direct response. 0.9. What is the ratio of the Value added (constant 2005 US$) in Agriculture in 1981 to that in 1984?
Provide a succinct answer. 0.83. What is the ratio of the Value added (constant 2005 US$) of Industry in 1981 to that in 1985?
Make the answer very short. 0.68. What is the ratio of the Value added (constant 2005 US$) in Services in 1981 to that in 1985?
Your response must be concise. 0.87. What is the ratio of the Value added (constant 2005 US$) in Agriculture in 1981 to that in 1985?
Your response must be concise. 0.77. What is the ratio of the Value added (constant 2005 US$) in Industry in 1981 to that in 1986?
Your answer should be compact. 0.73. What is the ratio of the Value added (constant 2005 US$) in Services in 1981 to that in 1986?
Keep it short and to the point. 1.01. What is the ratio of the Value added (constant 2005 US$) of Agriculture in 1981 to that in 1986?
Provide a short and direct response. 0.74. What is the ratio of the Value added (constant 2005 US$) of Industry in 1981 to that in 1987?
Your response must be concise. 0.67. What is the ratio of the Value added (constant 2005 US$) of Services in 1981 to that in 1987?
Offer a terse response. 1.09. What is the ratio of the Value added (constant 2005 US$) in Agriculture in 1981 to that in 1987?
Offer a very short reply. 0.72. What is the ratio of the Value added (constant 2005 US$) in Industry in 1981 to that in 1988?
Keep it short and to the point. 0.68. What is the ratio of the Value added (constant 2005 US$) in Services in 1981 to that in 1988?
Offer a terse response. 1.2. What is the ratio of the Value added (constant 2005 US$) in Agriculture in 1981 to that in 1988?
Ensure brevity in your answer.  0.72. What is the ratio of the Value added (constant 2005 US$) of Industry in 1982 to that in 1983?
Make the answer very short. 0.93. What is the ratio of the Value added (constant 2005 US$) of Services in 1982 to that in 1983?
Your response must be concise. 0.89. What is the ratio of the Value added (constant 2005 US$) of Agriculture in 1982 to that in 1983?
Offer a terse response. 0.96. What is the ratio of the Value added (constant 2005 US$) in Industry in 1982 to that in 1984?
Your answer should be very brief. 1.1. What is the ratio of the Value added (constant 2005 US$) of Services in 1982 to that in 1984?
Give a very brief answer. 0.91. What is the ratio of the Value added (constant 2005 US$) in Agriculture in 1982 to that in 1984?
Provide a succinct answer. 0.89. What is the ratio of the Value added (constant 2005 US$) of Industry in 1982 to that in 1985?
Provide a succinct answer. 1.11. What is the ratio of the Value added (constant 2005 US$) in Services in 1982 to that in 1985?
Ensure brevity in your answer.  0.88. What is the ratio of the Value added (constant 2005 US$) of Agriculture in 1982 to that in 1985?
Your answer should be very brief. 0.83. What is the ratio of the Value added (constant 2005 US$) of Industry in 1982 to that in 1986?
Ensure brevity in your answer.  1.19. What is the ratio of the Value added (constant 2005 US$) in Services in 1982 to that in 1986?
Your response must be concise. 1.02. What is the ratio of the Value added (constant 2005 US$) in Agriculture in 1982 to that in 1986?
Your response must be concise. 0.79. What is the ratio of the Value added (constant 2005 US$) in Industry in 1982 to that in 1987?
Your answer should be very brief. 1.1. What is the ratio of the Value added (constant 2005 US$) of Services in 1982 to that in 1987?
Keep it short and to the point. 1.1. What is the ratio of the Value added (constant 2005 US$) in Agriculture in 1982 to that in 1987?
Offer a very short reply. 0.77. What is the ratio of the Value added (constant 2005 US$) in Industry in 1982 to that in 1988?
Your response must be concise. 1.12. What is the ratio of the Value added (constant 2005 US$) of Services in 1982 to that in 1988?
Offer a terse response. 1.21. What is the ratio of the Value added (constant 2005 US$) in Agriculture in 1982 to that in 1988?
Provide a succinct answer. 0.77. What is the ratio of the Value added (constant 2005 US$) in Industry in 1983 to that in 1984?
Offer a very short reply. 1.18. What is the ratio of the Value added (constant 2005 US$) in Services in 1983 to that in 1984?
Your answer should be compact. 1.02. What is the ratio of the Value added (constant 2005 US$) of Agriculture in 1983 to that in 1984?
Make the answer very short. 0.93. What is the ratio of the Value added (constant 2005 US$) in Industry in 1983 to that in 1985?
Offer a terse response. 1.19. What is the ratio of the Value added (constant 2005 US$) in Services in 1983 to that in 1985?
Your response must be concise. 0.99. What is the ratio of the Value added (constant 2005 US$) of Agriculture in 1983 to that in 1985?
Your answer should be compact. 0.86. What is the ratio of the Value added (constant 2005 US$) in Industry in 1983 to that in 1986?
Your response must be concise. 1.28. What is the ratio of the Value added (constant 2005 US$) in Services in 1983 to that in 1986?
Your answer should be compact. 1.15. What is the ratio of the Value added (constant 2005 US$) of Agriculture in 1983 to that in 1986?
Give a very brief answer. 0.82. What is the ratio of the Value added (constant 2005 US$) in Industry in 1983 to that in 1987?
Give a very brief answer. 1.18. What is the ratio of the Value added (constant 2005 US$) in Services in 1983 to that in 1987?
Make the answer very short. 1.24. What is the ratio of the Value added (constant 2005 US$) of Agriculture in 1983 to that in 1987?
Your answer should be compact. 0.8. What is the ratio of the Value added (constant 2005 US$) in Industry in 1983 to that in 1988?
Ensure brevity in your answer.  1.2. What is the ratio of the Value added (constant 2005 US$) in Services in 1983 to that in 1988?
Provide a short and direct response. 1.36. What is the ratio of the Value added (constant 2005 US$) in Agriculture in 1983 to that in 1988?
Your response must be concise. 0.81. What is the ratio of the Value added (constant 2005 US$) of Industry in 1984 to that in 1985?
Offer a terse response. 1.01. What is the ratio of the Value added (constant 2005 US$) in Agriculture in 1984 to that in 1985?
Offer a very short reply. 0.93. What is the ratio of the Value added (constant 2005 US$) in Industry in 1984 to that in 1986?
Provide a succinct answer. 1.08. What is the ratio of the Value added (constant 2005 US$) in Services in 1984 to that in 1986?
Keep it short and to the point. 1.12. What is the ratio of the Value added (constant 2005 US$) of Agriculture in 1984 to that in 1986?
Ensure brevity in your answer.  0.88. What is the ratio of the Value added (constant 2005 US$) of Services in 1984 to that in 1987?
Your answer should be compact. 1.21. What is the ratio of the Value added (constant 2005 US$) in Agriculture in 1984 to that in 1987?
Provide a succinct answer. 0.86. What is the ratio of the Value added (constant 2005 US$) of Industry in 1984 to that in 1988?
Provide a short and direct response. 1.01. What is the ratio of the Value added (constant 2005 US$) of Services in 1984 to that in 1988?
Give a very brief answer. 1.33. What is the ratio of the Value added (constant 2005 US$) in Agriculture in 1984 to that in 1988?
Provide a short and direct response. 0.87. What is the ratio of the Value added (constant 2005 US$) of Industry in 1985 to that in 1986?
Your answer should be very brief. 1.07. What is the ratio of the Value added (constant 2005 US$) of Services in 1985 to that in 1986?
Provide a succinct answer. 1.16. What is the ratio of the Value added (constant 2005 US$) in Agriculture in 1985 to that in 1986?
Your response must be concise. 0.95. What is the ratio of the Value added (constant 2005 US$) of Industry in 1985 to that in 1987?
Provide a short and direct response. 0.99. What is the ratio of the Value added (constant 2005 US$) of Services in 1985 to that in 1987?
Provide a short and direct response. 1.25. What is the ratio of the Value added (constant 2005 US$) in Agriculture in 1985 to that in 1987?
Your answer should be very brief. 0.93. What is the ratio of the Value added (constant 2005 US$) in Services in 1985 to that in 1988?
Your response must be concise. 1.38. What is the ratio of the Value added (constant 2005 US$) of Agriculture in 1985 to that in 1988?
Your response must be concise. 0.94. What is the ratio of the Value added (constant 2005 US$) of Industry in 1986 to that in 1987?
Give a very brief answer. 0.92. What is the ratio of the Value added (constant 2005 US$) of Services in 1986 to that in 1987?
Provide a short and direct response. 1.08. What is the ratio of the Value added (constant 2005 US$) in Agriculture in 1986 to that in 1987?
Your answer should be very brief. 0.98. What is the ratio of the Value added (constant 2005 US$) of Industry in 1986 to that in 1988?
Your answer should be compact. 0.94. What is the ratio of the Value added (constant 2005 US$) in Services in 1986 to that in 1988?
Keep it short and to the point. 1.19. What is the ratio of the Value added (constant 2005 US$) of Agriculture in 1986 to that in 1988?
Make the answer very short. 0.98. What is the ratio of the Value added (constant 2005 US$) in Industry in 1987 to that in 1988?
Offer a terse response. 1.02. What is the ratio of the Value added (constant 2005 US$) of Services in 1987 to that in 1988?
Your answer should be compact. 1.1. What is the ratio of the Value added (constant 2005 US$) in Agriculture in 1987 to that in 1988?
Make the answer very short. 1.01. What is the difference between the highest and the second highest Value added (constant 2005 US$) of Industry?
Offer a terse response. 3.99e+09. What is the difference between the highest and the second highest Value added (constant 2005 US$) of Services?
Give a very brief answer. 6.70e+08. What is the difference between the highest and the second highest Value added (constant 2005 US$) of Agriculture?
Your answer should be very brief. 4.59e+07. What is the difference between the highest and the lowest Value added (constant 2005 US$) of Industry?
Offer a very short reply. 2.53e+1. What is the difference between the highest and the lowest Value added (constant 2005 US$) of Services?
Give a very brief answer. 1.64e+1. What is the difference between the highest and the lowest Value added (constant 2005 US$) of Agriculture?
Make the answer very short. 2.11e+09. 